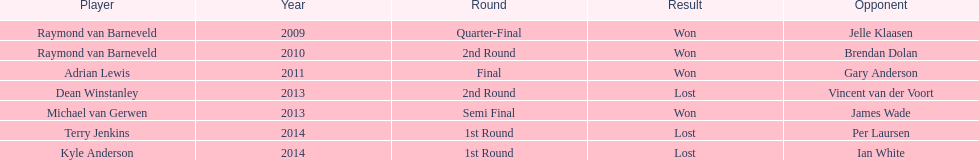In 2014, did terry jenkins or per laursen emerge victorious? Per Laursen. 